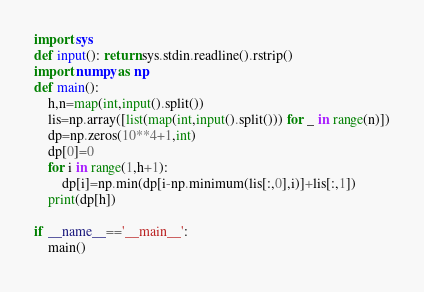<code> <loc_0><loc_0><loc_500><loc_500><_Python_>import sys
def input(): return sys.stdin.readline().rstrip()
import numpy as np
def main():
    h,n=map(int,input().split())
    lis=np.array([list(map(int,input().split())) for _ in range(n)])
    dp=np.zeros(10**4+1,int)
    dp[0]=0
    for i in range(1,h+1):
        dp[i]=np.min(dp[i-np.minimum(lis[:,0],i)]+lis[:,1])
    print(dp[h])

if __name__=='__main__':
    main()</code> 